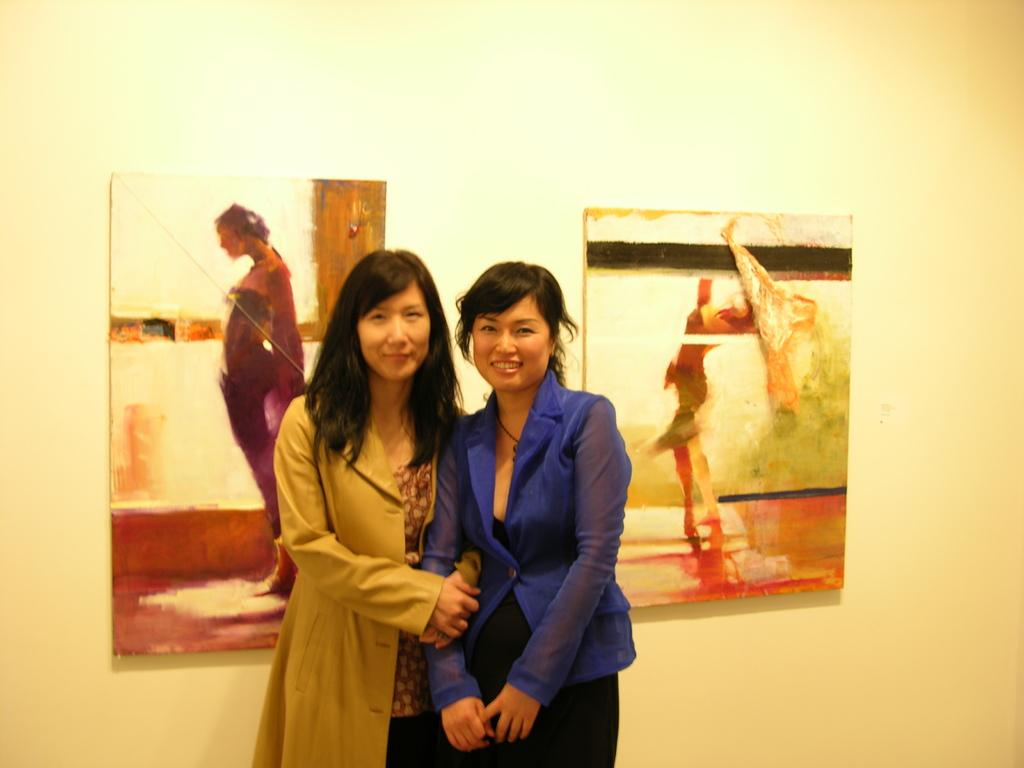How many women are in the image? There are two women in the image. What colors are the coats worn by the women? One woman is wearing a brown coat, and the other woman is wearing a blue coat. What can be seen on the wall in the background? There are frames attached to the wall in the background. What colors are used for the wall in the background? The wall is white and cream in color. Can you tell me how the women are stepping through the quicksand in the image? There is no quicksand present in the image; it features two women wearing coats and a wall with frames. 